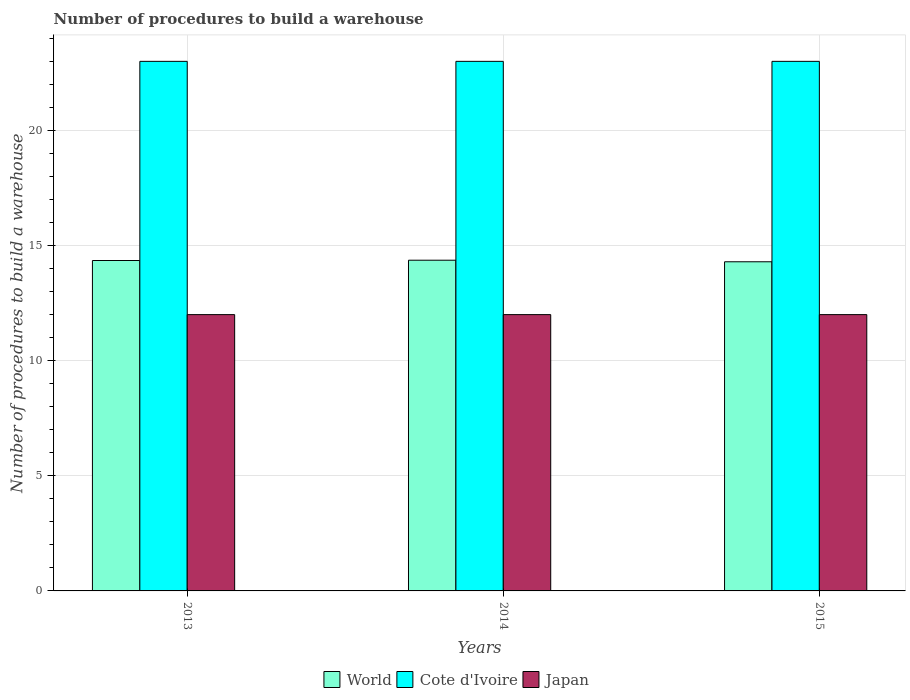How many different coloured bars are there?
Keep it short and to the point. 3. Are the number of bars on each tick of the X-axis equal?
Your response must be concise. Yes. What is the label of the 3rd group of bars from the left?
Ensure brevity in your answer.  2015. What is the number of procedures to build a warehouse in in World in 2015?
Offer a very short reply. 14.3. Across all years, what is the maximum number of procedures to build a warehouse in in World?
Your answer should be very brief. 14.36. Across all years, what is the minimum number of procedures to build a warehouse in in Japan?
Make the answer very short. 12. In which year was the number of procedures to build a warehouse in in Japan minimum?
Your answer should be very brief. 2013. What is the total number of procedures to build a warehouse in in Cote d'Ivoire in the graph?
Make the answer very short. 69. What is the difference between the number of procedures to build a warehouse in in World in 2014 and that in 2015?
Provide a succinct answer. 0.07. What is the difference between the number of procedures to build a warehouse in in World in 2014 and the number of procedures to build a warehouse in in Cote d'Ivoire in 2013?
Your response must be concise. -8.64. What is the ratio of the number of procedures to build a warehouse in in World in 2014 to that in 2015?
Ensure brevity in your answer.  1. What does the 3rd bar from the left in 2014 represents?
Offer a very short reply. Japan. Is it the case that in every year, the sum of the number of procedures to build a warehouse in in Japan and number of procedures to build a warehouse in in Cote d'Ivoire is greater than the number of procedures to build a warehouse in in World?
Make the answer very short. Yes. Are the values on the major ticks of Y-axis written in scientific E-notation?
Offer a very short reply. No. Does the graph contain any zero values?
Your answer should be very brief. No. Does the graph contain grids?
Keep it short and to the point. Yes. How many legend labels are there?
Provide a short and direct response. 3. How are the legend labels stacked?
Your answer should be very brief. Horizontal. What is the title of the graph?
Your response must be concise. Number of procedures to build a warehouse. Does "Egypt, Arab Rep." appear as one of the legend labels in the graph?
Your answer should be compact. No. What is the label or title of the Y-axis?
Offer a very short reply. Number of procedures to build a warehouse. What is the Number of procedures to build a warehouse of World in 2013?
Provide a succinct answer. 14.35. What is the Number of procedures to build a warehouse of Japan in 2013?
Ensure brevity in your answer.  12. What is the Number of procedures to build a warehouse of World in 2014?
Provide a short and direct response. 14.36. What is the Number of procedures to build a warehouse of World in 2015?
Your answer should be very brief. 14.3. What is the Number of procedures to build a warehouse in Cote d'Ivoire in 2015?
Keep it short and to the point. 23. Across all years, what is the maximum Number of procedures to build a warehouse in World?
Make the answer very short. 14.36. Across all years, what is the maximum Number of procedures to build a warehouse of Japan?
Your response must be concise. 12. Across all years, what is the minimum Number of procedures to build a warehouse of World?
Offer a terse response. 14.3. Across all years, what is the minimum Number of procedures to build a warehouse of Japan?
Offer a very short reply. 12. What is the total Number of procedures to build a warehouse of World in the graph?
Offer a very short reply. 43.01. What is the total Number of procedures to build a warehouse of Cote d'Ivoire in the graph?
Your answer should be compact. 69. What is the total Number of procedures to build a warehouse of Japan in the graph?
Offer a terse response. 36. What is the difference between the Number of procedures to build a warehouse of World in 2013 and that in 2014?
Make the answer very short. -0.01. What is the difference between the Number of procedures to build a warehouse of Cote d'Ivoire in 2013 and that in 2014?
Your answer should be very brief. 0. What is the difference between the Number of procedures to build a warehouse in Japan in 2013 and that in 2014?
Make the answer very short. 0. What is the difference between the Number of procedures to build a warehouse of World in 2013 and that in 2015?
Make the answer very short. 0.06. What is the difference between the Number of procedures to build a warehouse in World in 2014 and that in 2015?
Your response must be concise. 0.07. What is the difference between the Number of procedures to build a warehouse of Cote d'Ivoire in 2014 and that in 2015?
Provide a succinct answer. 0. What is the difference between the Number of procedures to build a warehouse in World in 2013 and the Number of procedures to build a warehouse in Cote d'Ivoire in 2014?
Offer a terse response. -8.65. What is the difference between the Number of procedures to build a warehouse in World in 2013 and the Number of procedures to build a warehouse in Japan in 2014?
Offer a very short reply. 2.35. What is the difference between the Number of procedures to build a warehouse of World in 2013 and the Number of procedures to build a warehouse of Cote d'Ivoire in 2015?
Provide a short and direct response. -8.65. What is the difference between the Number of procedures to build a warehouse in World in 2013 and the Number of procedures to build a warehouse in Japan in 2015?
Your response must be concise. 2.35. What is the difference between the Number of procedures to build a warehouse of Cote d'Ivoire in 2013 and the Number of procedures to build a warehouse of Japan in 2015?
Offer a very short reply. 11. What is the difference between the Number of procedures to build a warehouse of World in 2014 and the Number of procedures to build a warehouse of Cote d'Ivoire in 2015?
Ensure brevity in your answer.  -8.64. What is the difference between the Number of procedures to build a warehouse in World in 2014 and the Number of procedures to build a warehouse in Japan in 2015?
Offer a very short reply. 2.36. What is the difference between the Number of procedures to build a warehouse of Cote d'Ivoire in 2014 and the Number of procedures to build a warehouse of Japan in 2015?
Your response must be concise. 11. What is the average Number of procedures to build a warehouse of World per year?
Make the answer very short. 14.34. In the year 2013, what is the difference between the Number of procedures to build a warehouse in World and Number of procedures to build a warehouse in Cote d'Ivoire?
Keep it short and to the point. -8.65. In the year 2013, what is the difference between the Number of procedures to build a warehouse of World and Number of procedures to build a warehouse of Japan?
Make the answer very short. 2.35. In the year 2013, what is the difference between the Number of procedures to build a warehouse of Cote d'Ivoire and Number of procedures to build a warehouse of Japan?
Make the answer very short. 11. In the year 2014, what is the difference between the Number of procedures to build a warehouse of World and Number of procedures to build a warehouse of Cote d'Ivoire?
Your answer should be compact. -8.64. In the year 2014, what is the difference between the Number of procedures to build a warehouse in World and Number of procedures to build a warehouse in Japan?
Make the answer very short. 2.36. In the year 2014, what is the difference between the Number of procedures to build a warehouse of Cote d'Ivoire and Number of procedures to build a warehouse of Japan?
Your answer should be very brief. 11. In the year 2015, what is the difference between the Number of procedures to build a warehouse in World and Number of procedures to build a warehouse in Cote d'Ivoire?
Offer a terse response. -8.7. In the year 2015, what is the difference between the Number of procedures to build a warehouse in World and Number of procedures to build a warehouse in Japan?
Your response must be concise. 2.3. What is the ratio of the Number of procedures to build a warehouse of World in 2013 to that in 2015?
Give a very brief answer. 1. What is the ratio of the Number of procedures to build a warehouse in Japan in 2013 to that in 2015?
Make the answer very short. 1. What is the difference between the highest and the second highest Number of procedures to build a warehouse in World?
Provide a succinct answer. 0.01. What is the difference between the highest and the second highest Number of procedures to build a warehouse of Cote d'Ivoire?
Ensure brevity in your answer.  0. What is the difference between the highest and the second highest Number of procedures to build a warehouse of Japan?
Your answer should be very brief. 0. What is the difference between the highest and the lowest Number of procedures to build a warehouse in World?
Your answer should be very brief. 0.07. What is the difference between the highest and the lowest Number of procedures to build a warehouse of Japan?
Make the answer very short. 0. 